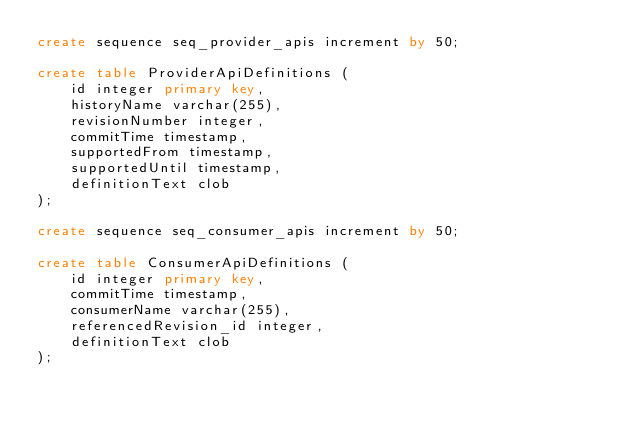<code> <loc_0><loc_0><loc_500><loc_500><_SQL_>create sequence seq_provider_apis increment by 50;

create table ProviderApiDefinitions (
    id integer primary key,
    historyName varchar(255),
    revisionNumber integer,
    commitTime timestamp,
    supportedFrom timestamp,
    supportedUntil timestamp,
    definitionText clob
);

create sequence seq_consumer_apis increment by 50;

create table ConsumerApiDefinitions (
    id integer primary key,
    commitTime timestamp,
    consumerName varchar(255),
    referencedRevision_id integer,
    definitionText clob
);
</code> 